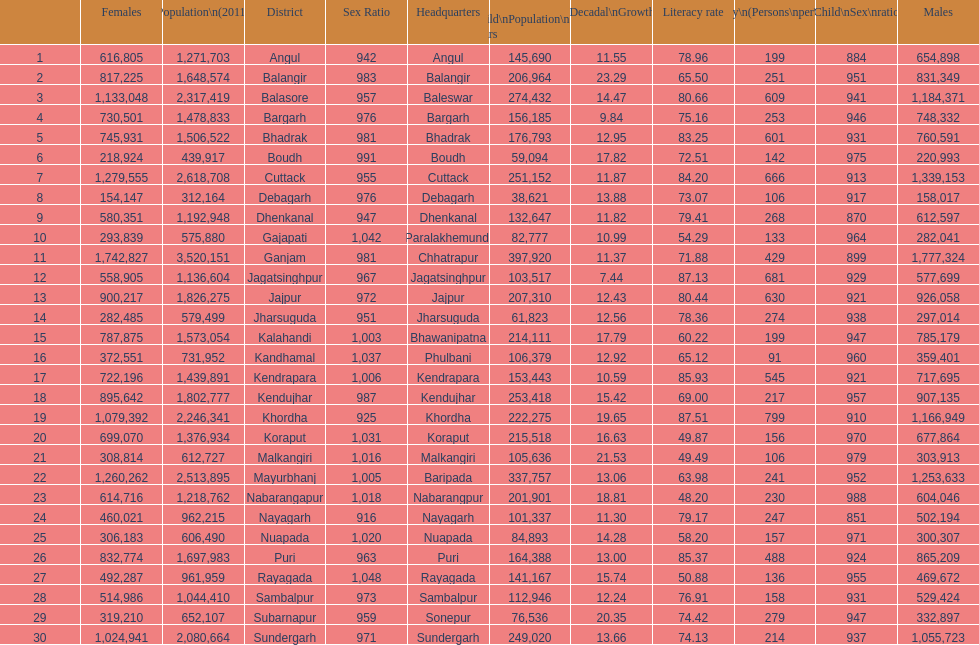What is the number of districts with percentage decadal growth above 15% 10. 